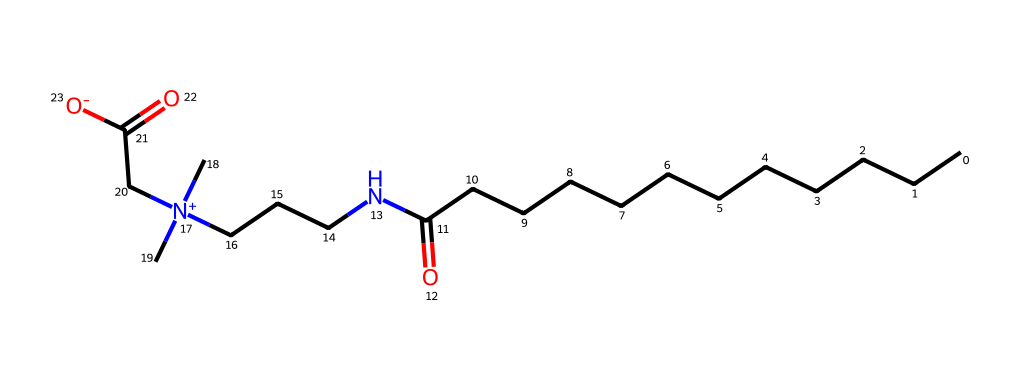What is the molecular formula of cocamidopropyl betaine? To determine the molecular formula, I can analyze the components represented in the SMILES notation. The structure has carbon (C), hydrogen (H), nitrogen (N), and oxygen (O) atoms, which I can count. The total counts are: 14 carbons, 29 hydrogens, 2 nitrogens, and 2 oxygens, leading to the molecular formula C14H29N2O2.
Answer: C14H29N2O2 How many carbon atoms are present in cocamidopropyl betaine? Counting the carbon atoms from the SMILES representation indicates there are 14 carbon atoms present, indicated by the 'C' in the structure.
Answer: 14 What functional groups are present in cocamidopropyl betaine? The functional groups evident in the structure include a carboxylic acid group (—COOH) and a quaternary ammonium group (indicated by [N+]). Each group can be identified through their characteristic bonding patterns present in the molecular structure.
Answer: carboxylic acid, quaternary ammonium What does the presence of a quaternary ammonium group suggest about the properties of cocamidopropyl betaine? The presence of a quaternary ammonium group indicates that cocamidopropyl betaine is a surfactant known for its amphiphilic nature. This means that it contains both hydrophilic (water-attracting) and hydrophobic (water-repelling) parts, allowing it to effectively reduce surface tension and mix with both oil and water, which is characteristic of surfactants.
Answer: amphiphilic What type of surfactant is cocamidopropyl betaine categorized as? Cocamidopropyl betaine is categorized as an amphoteric surfactant because it has both positive and negative charges in its structure. This property allows it to behave both as a cationic and an anionic surfactant depending on the pH of the solution, which is specific to this type of surfactant.
Answer: amphoteric What role does cocamidopropyl betaine play in personal care products? Cocamidopropyl betaine acts primarily as a foam booster and mild surfactant in personal care formulations. Its structural properties make it effective at improving the texture and performance of products, particularly in cleansing applications such as shampoos and body washes.
Answer: foam booster, mild surfactant 